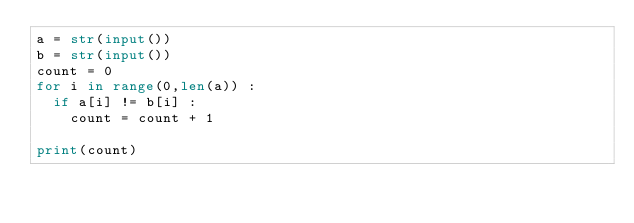<code> <loc_0><loc_0><loc_500><loc_500><_Python_>a = str(input())
b = str(input())
count = 0
for i in range(0,len(a)) :
  if a[i] != b[i] :
    count = count + 1

print(count)</code> 